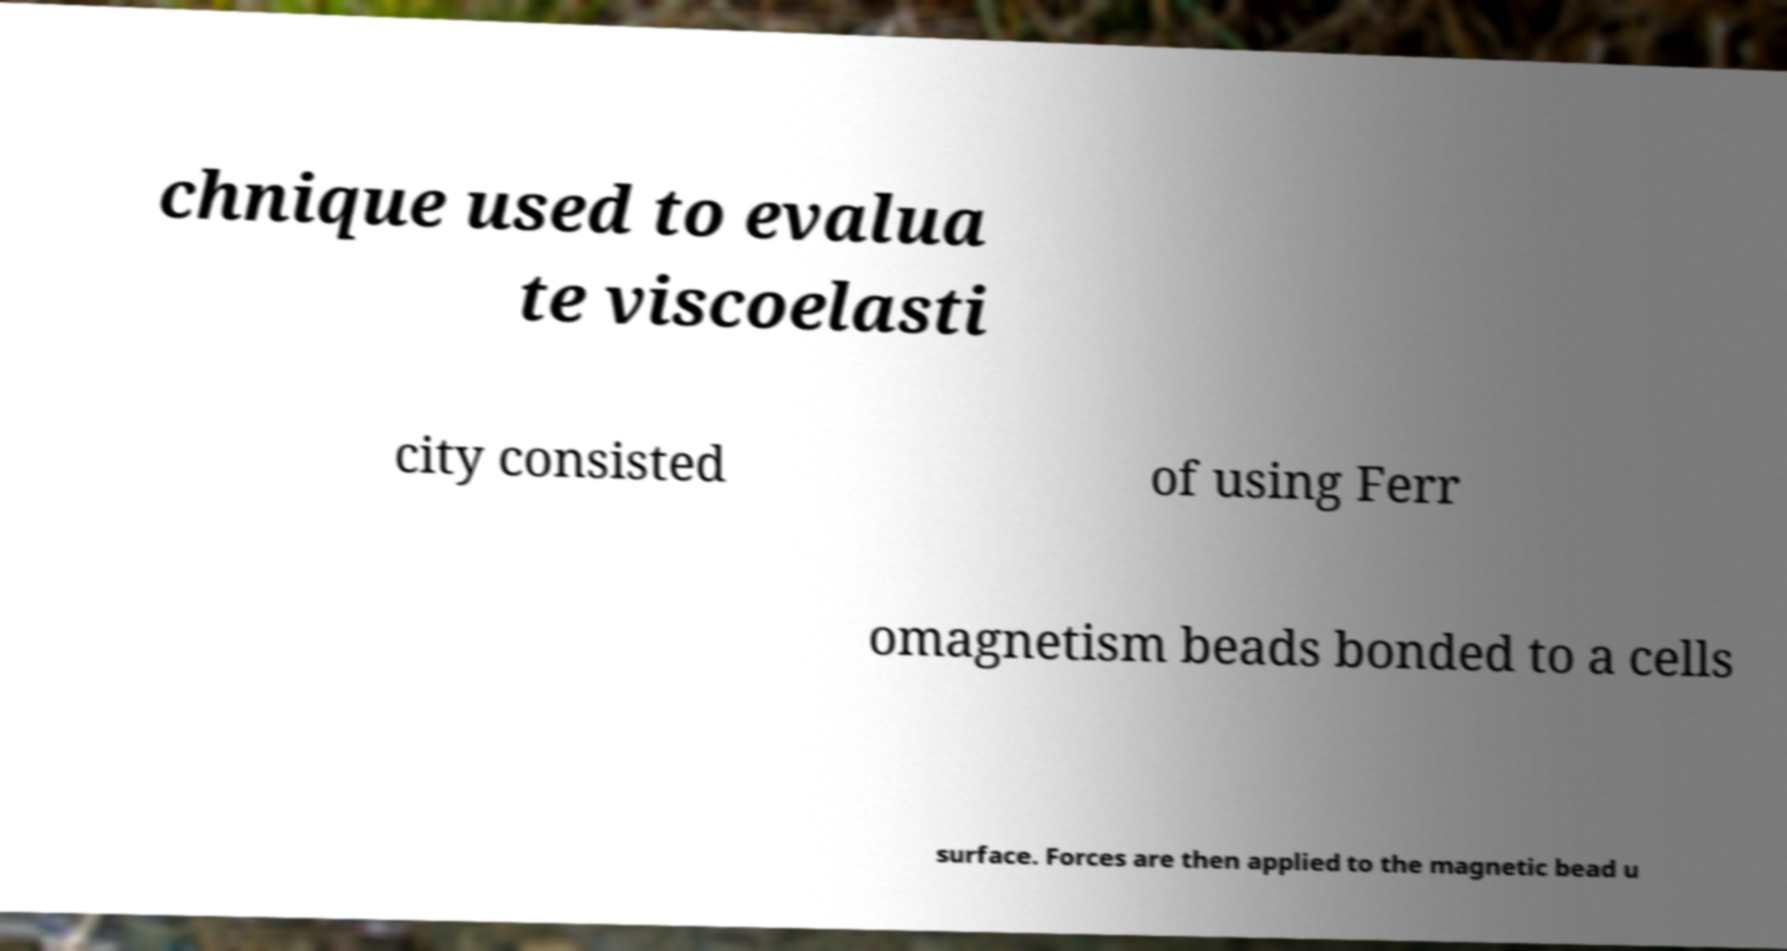I need the written content from this picture converted into text. Can you do that? chnique used to evalua te viscoelasti city consisted of using Ferr omagnetism beads bonded to a cells surface. Forces are then applied to the magnetic bead u 